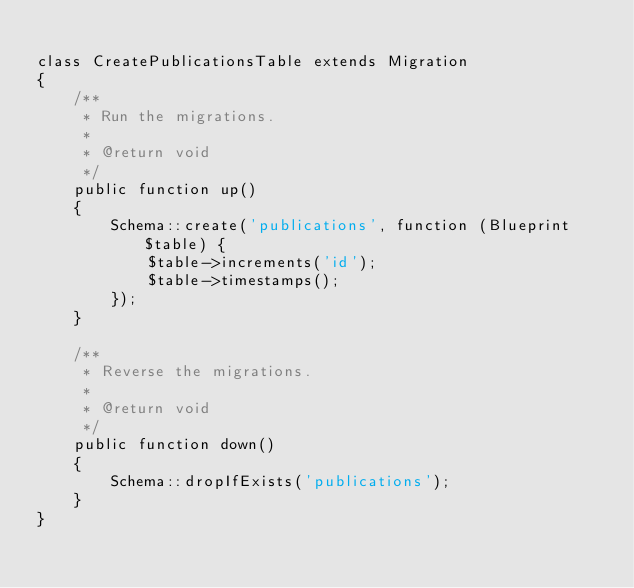Convert code to text. <code><loc_0><loc_0><loc_500><loc_500><_PHP_>
class CreatePublicationsTable extends Migration
{
    /**
     * Run the migrations.
     *
     * @return void
     */
    public function up()
    {
        Schema::create('publications', function (Blueprint $table) {
            $table->increments('id');
            $table->timestamps();
        });
    }

    /**
     * Reverse the migrations.
     *
     * @return void
     */
    public function down()
    {
        Schema::dropIfExists('publications');
    }
}
</code> 